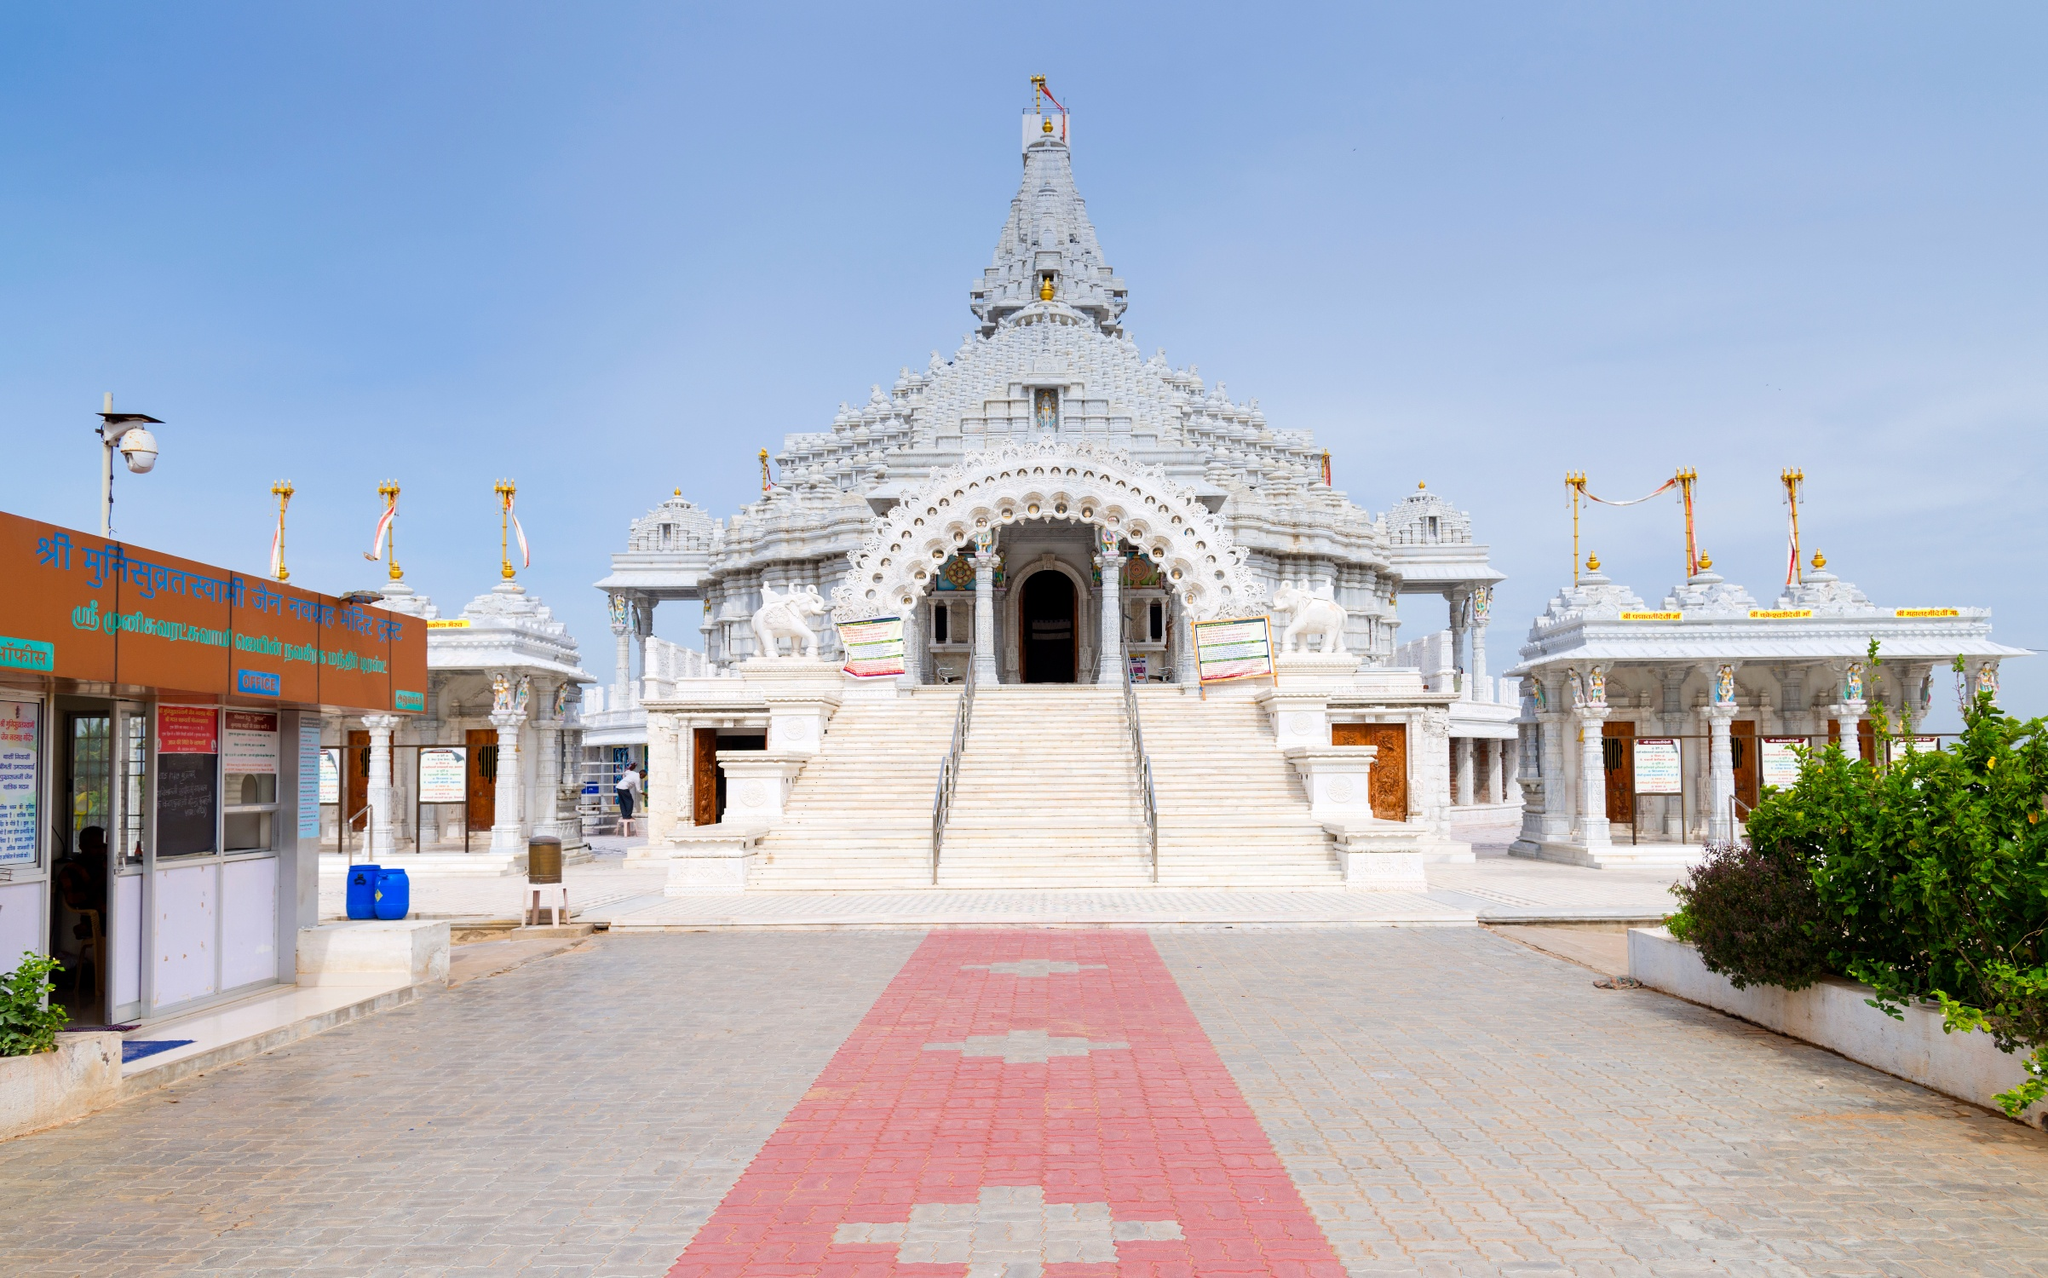Describe the following image. The image showcases the Shri Swaminarayan Mandir, a renowned Hindu temple located in Bhuj, India. The temple, constructed from white marble, stands majestically against the backdrop of a clear blue sky with a few scattered clouds. A tall spire, adorned with a golden flag, rises from the center of the temple, signifying its spiritual significance. The entrance of the temple is marked by two golden pillars, adding to the grandeur of the structure. The roof of the temple is dotted with several smaller golden pillars, enhancing its architectural beauty. Surrounding the temple is a red brick pathway, providing a stark contrast to the green shrubbery that encircles the temple premises. The overall image presents a serene and peaceful atmosphere, characteristic of such spiritual landmarks. 